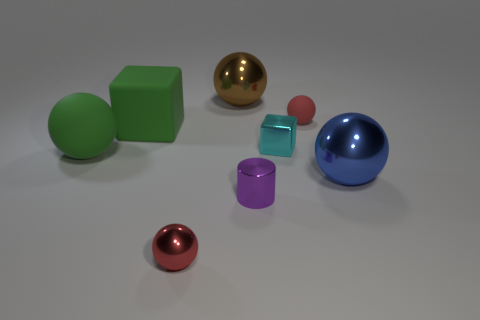There is a sphere that is the same color as the big rubber block; what is its size?
Your response must be concise. Large. What is the shape of the large rubber thing that is the same color as the matte block?
Keep it short and to the point. Sphere. Is there any other thing that has the same color as the rubber block?
Your answer should be compact. Yes. There is a big matte thing that is right of the large rubber sphere; does it have the same color as the rubber object in front of the cyan metallic block?
Give a very brief answer. Yes. There is a tiny metal sphere; does it have the same color as the matte thing on the right side of the metallic cylinder?
Keep it short and to the point. Yes. Does the red rubber thing have the same shape as the brown metallic object?
Make the answer very short. Yes. There is a green object that is right of the green rubber ball; what number of tiny purple metallic cylinders are on the right side of it?
Ensure brevity in your answer.  1. There is a tiny purple object that is made of the same material as the blue sphere; what is its shape?
Your answer should be very brief. Cylinder. How many purple objects are big metallic spheres or metallic cylinders?
Provide a succinct answer. 1. There is a small red thing that is behind the shiny thing that is on the left side of the brown thing; is there a small red shiny object to the left of it?
Offer a terse response. Yes. 